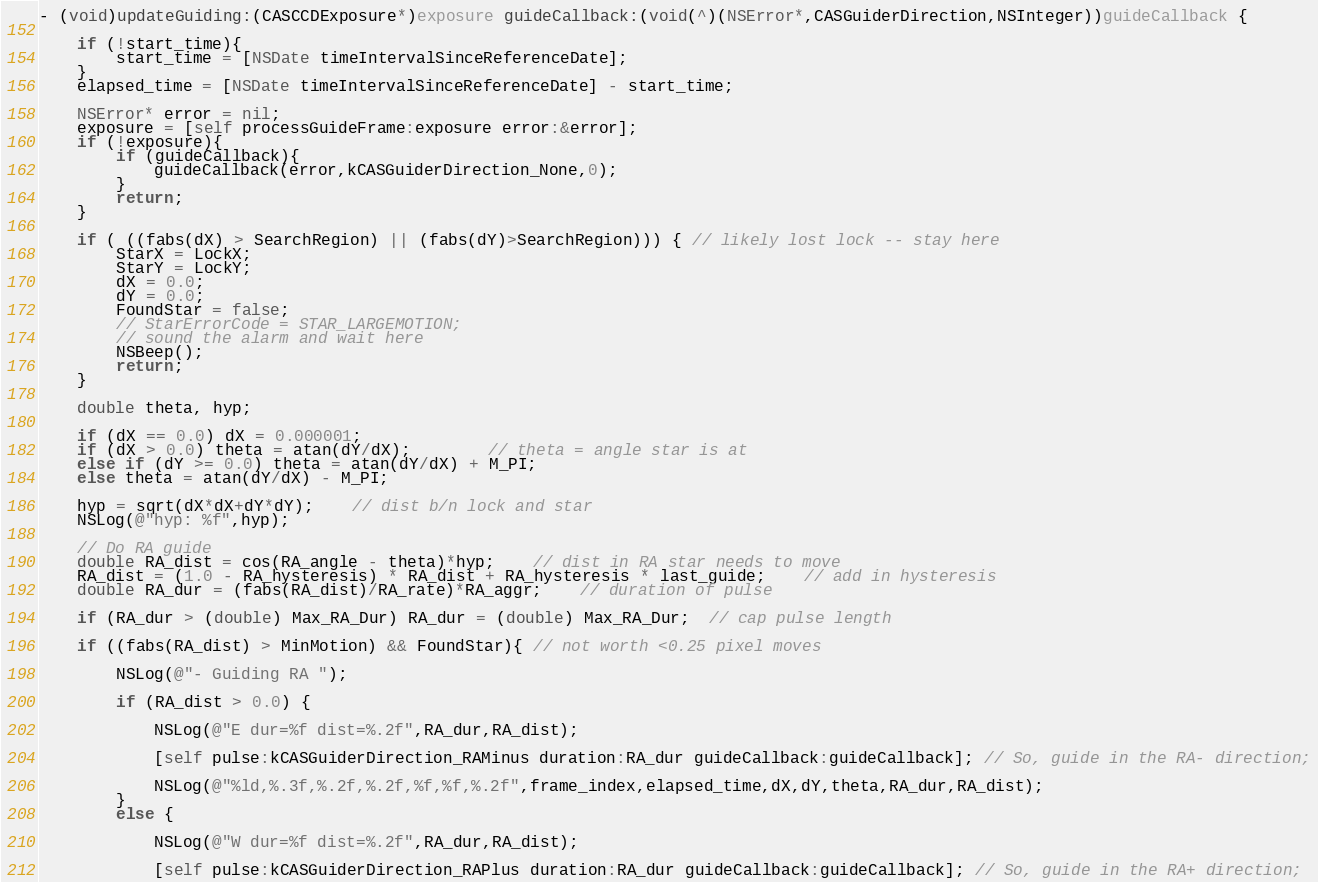<code> <loc_0><loc_0><loc_500><loc_500><_ObjectiveC_>- (void)updateGuiding:(CASCCDExposure*)exposure guideCallback:(void(^)(NSError*,CASGuiderDirection,NSInteger))guideCallback {
    
    if (!start_time){
        start_time = [NSDate timeIntervalSinceReferenceDate];
    }
    elapsed_time = [NSDate timeIntervalSinceReferenceDate] - start_time;
    
    NSError* error = nil;
    exposure = [self processGuideFrame:exposure error:&error];
    if (!exposure){
        if (guideCallback){
            guideCallback(error,kCASGuiderDirection_None,0);
        }
        return;
    }
    
    if ( ((fabs(dX) > SearchRegion) || (fabs(dY)>SearchRegion))) { // likely lost lock -- stay here
        StarX = LockX;
        StarY = LockY;
        dX = 0.0;
        dY = 0.0;
        FoundStar = false;
        // StarErrorCode = STAR_LARGEMOTION;
        // sound the alarm and wait here
        NSBeep();
        return;
    }
    
    double theta, hyp;

    if (dX == 0.0) dX = 0.000001;
    if (dX > 0.0) theta = atan(dY/dX);		// theta = angle star is at
    else if (dY >= 0.0) theta = atan(dY/dX) + M_PI;
    else theta = atan(dY/dX) - M_PI;
    
    hyp = sqrt(dX*dX+dY*dY);	// dist b/n lock and star
    NSLog(@"hyp: %f",hyp);
    
    // Do RA guide
    double RA_dist = cos(RA_angle - theta)*hyp;	// dist in RA star needs to move
    RA_dist = (1.0 - RA_hysteresis) * RA_dist + RA_hysteresis * last_guide;	// add in hysteresis
    double RA_dur = (fabs(RA_dist)/RA_rate)*RA_aggr;	// duration of pulse

    if (RA_dur > (double) Max_RA_Dur) RA_dur = (double) Max_RA_Dur;  // cap pulse length
    
    if ((fabs(RA_dist) > MinMotion) && FoundStar){ // not worth <0.25 pixel moves
        
        NSLog(@"- Guiding RA ");
        
        if (RA_dist > 0.0) {
            
            NSLog(@"E dur=%f dist=%.2f",RA_dur,RA_dist);
            
            [self pulse:kCASGuiderDirection_RAMinus duration:RA_dur guideCallback:guideCallback]; // So, guide in the RA- direction;

            NSLog(@"%ld,%.3f,%.2f,%.2f,%f,%f,%.2f",frame_index,elapsed_time,dX,dY,theta,RA_dur,RA_dist);
        }
        else {
            
            NSLog(@"W dur=%f dist=%.2f",RA_dur,RA_dist);
            
            [self pulse:kCASGuiderDirection_RAPlus duration:RA_dur guideCallback:guideCallback]; // So, guide in the RA+ direction;
</code> 